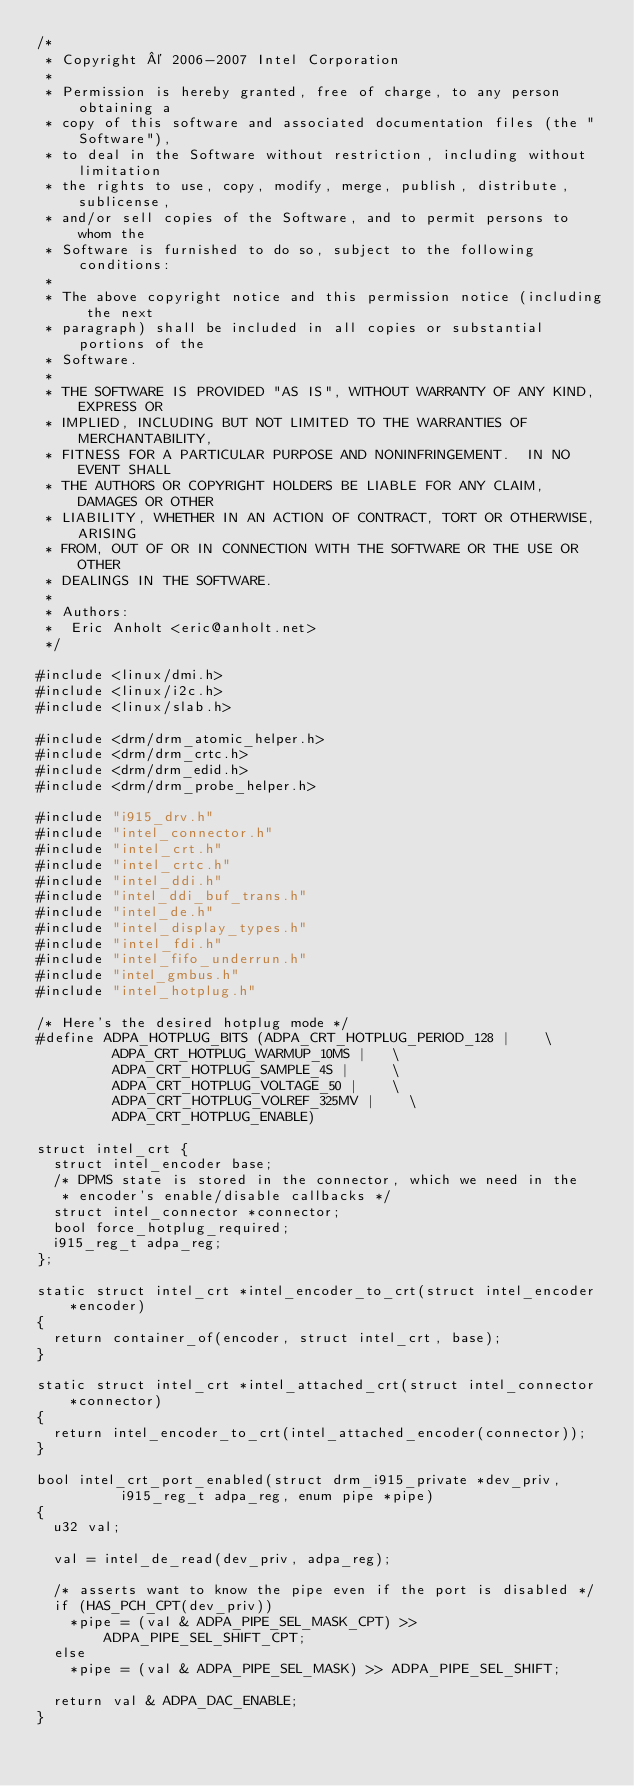<code> <loc_0><loc_0><loc_500><loc_500><_C_>/*
 * Copyright © 2006-2007 Intel Corporation
 *
 * Permission is hereby granted, free of charge, to any person obtaining a
 * copy of this software and associated documentation files (the "Software"),
 * to deal in the Software without restriction, including without limitation
 * the rights to use, copy, modify, merge, publish, distribute, sublicense,
 * and/or sell copies of the Software, and to permit persons to whom the
 * Software is furnished to do so, subject to the following conditions:
 *
 * The above copyright notice and this permission notice (including the next
 * paragraph) shall be included in all copies or substantial portions of the
 * Software.
 *
 * THE SOFTWARE IS PROVIDED "AS IS", WITHOUT WARRANTY OF ANY KIND, EXPRESS OR
 * IMPLIED, INCLUDING BUT NOT LIMITED TO THE WARRANTIES OF MERCHANTABILITY,
 * FITNESS FOR A PARTICULAR PURPOSE AND NONINFRINGEMENT.  IN NO EVENT SHALL
 * THE AUTHORS OR COPYRIGHT HOLDERS BE LIABLE FOR ANY CLAIM, DAMAGES OR OTHER
 * LIABILITY, WHETHER IN AN ACTION OF CONTRACT, TORT OR OTHERWISE, ARISING
 * FROM, OUT OF OR IN CONNECTION WITH THE SOFTWARE OR THE USE OR OTHER
 * DEALINGS IN THE SOFTWARE.
 *
 * Authors:
 *	Eric Anholt <eric@anholt.net>
 */

#include <linux/dmi.h>
#include <linux/i2c.h>
#include <linux/slab.h>

#include <drm/drm_atomic_helper.h>
#include <drm/drm_crtc.h>
#include <drm/drm_edid.h>
#include <drm/drm_probe_helper.h>

#include "i915_drv.h"
#include "intel_connector.h"
#include "intel_crt.h"
#include "intel_crtc.h"
#include "intel_ddi.h"
#include "intel_ddi_buf_trans.h"
#include "intel_de.h"
#include "intel_display_types.h"
#include "intel_fdi.h"
#include "intel_fifo_underrun.h"
#include "intel_gmbus.h"
#include "intel_hotplug.h"

/* Here's the desired hotplug mode */
#define ADPA_HOTPLUG_BITS (ADPA_CRT_HOTPLUG_PERIOD_128 |		\
			   ADPA_CRT_HOTPLUG_WARMUP_10MS |		\
			   ADPA_CRT_HOTPLUG_SAMPLE_4S |			\
			   ADPA_CRT_HOTPLUG_VOLTAGE_50 |		\
			   ADPA_CRT_HOTPLUG_VOLREF_325MV |		\
			   ADPA_CRT_HOTPLUG_ENABLE)

struct intel_crt {
	struct intel_encoder base;
	/* DPMS state is stored in the connector, which we need in the
	 * encoder's enable/disable callbacks */
	struct intel_connector *connector;
	bool force_hotplug_required;
	i915_reg_t adpa_reg;
};

static struct intel_crt *intel_encoder_to_crt(struct intel_encoder *encoder)
{
	return container_of(encoder, struct intel_crt, base);
}

static struct intel_crt *intel_attached_crt(struct intel_connector *connector)
{
	return intel_encoder_to_crt(intel_attached_encoder(connector));
}

bool intel_crt_port_enabled(struct drm_i915_private *dev_priv,
			    i915_reg_t adpa_reg, enum pipe *pipe)
{
	u32 val;

	val = intel_de_read(dev_priv, adpa_reg);

	/* asserts want to know the pipe even if the port is disabled */
	if (HAS_PCH_CPT(dev_priv))
		*pipe = (val & ADPA_PIPE_SEL_MASK_CPT) >> ADPA_PIPE_SEL_SHIFT_CPT;
	else
		*pipe = (val & ADPA_PIPE_SEL_MASK) >> ADPA_PIPE_SEL_SHIFT;

	return val & ADPA_DAC_ENABLE;
}
</code> 